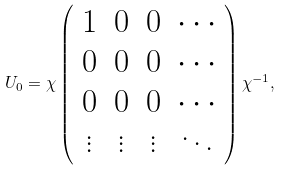Convert formula to latex. <formula><loc_0><loc_0><loc_500><loc_500>U _ { 0 } = \chi \left ( \begin{array} { c c c c } 1 & 0 & 0 & \cdots \\ 0 & 0 & 0 & \cdots \\ 0 & 0 & 0 & \cdots \\ \vdots & \vdots & \vdots & \ddots \end{array} \right ) \chi ^ { - 1 } , \\</formula> 